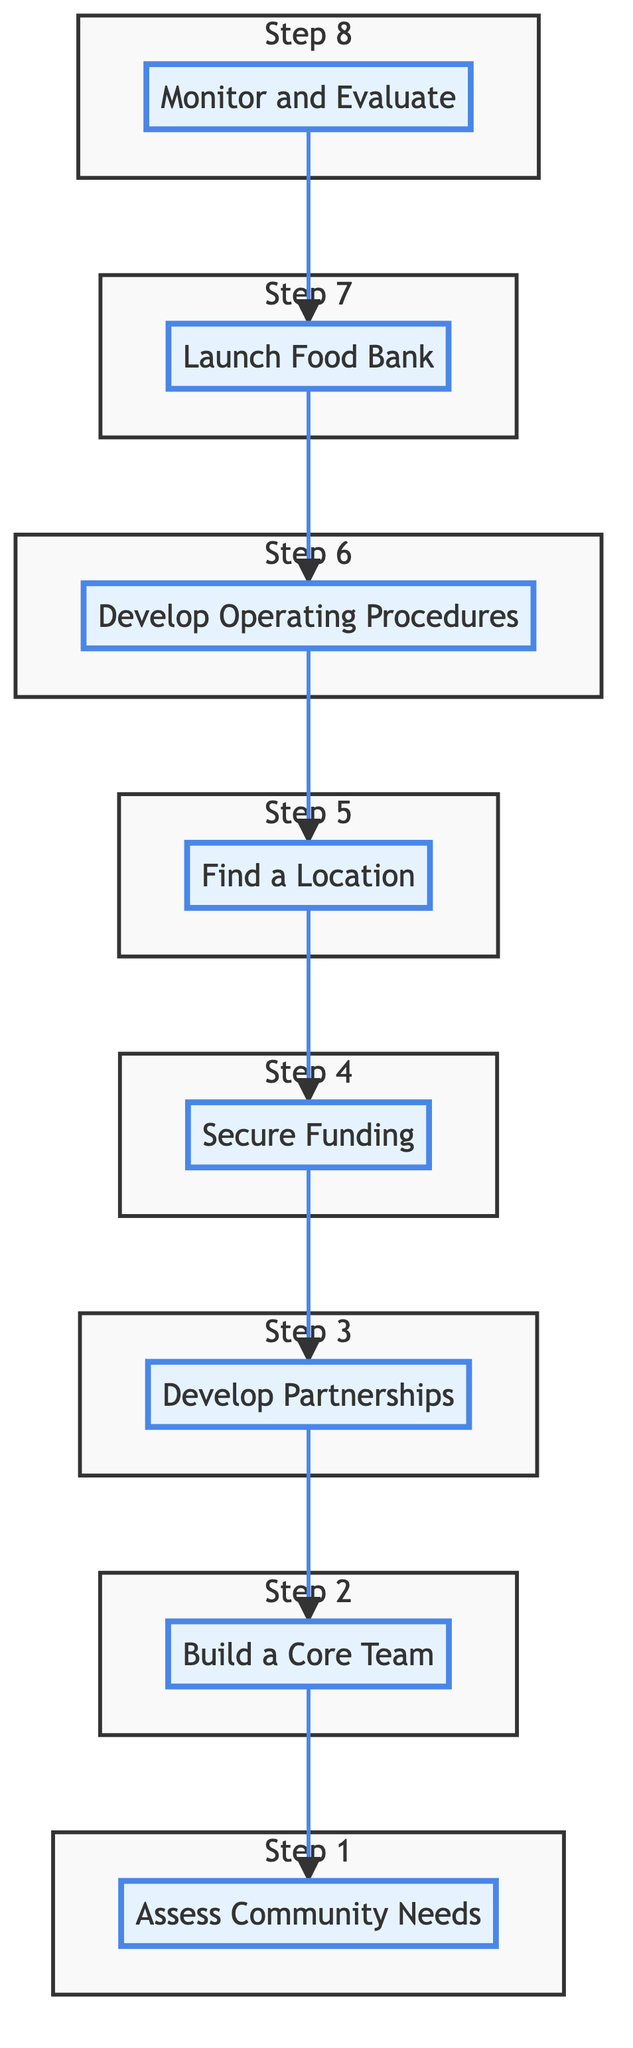What's the first step in establishing a local food bank? The diagram begins with the first node labeled "Assess Community Needs," which signifies the initial step to identify food insecurity levels and demographics.
Answer: Assess Community Needs How many total steps are in the pathway to establish a local food bank? Counting the nodes from the diagram, there are eight steps listed, each representing a key stage in establishing the food bank.
Answer: Eight Which step comes directly after securing funding? Observing the flow of the diagram, the step labeled "Find a Location" follows directly after "Secure Funding," indicating the subsequent action taken.
Answer: Find a Location What type of entities are involved in the "Develop Partnerships" step? According to the diagram, "Develop Partnerships" involves entities such as grocery stores, local farms, and charitable organizations that help secure resources and support.
Answer: Grocery Stores, Local Farms, Charitable Organizations Which step concludes the process of establishing a local food bank? The final step in the flow chart is "Monitor and Evaluate," which indicates that this is the concluding action to ensure the food bank is efficient and meets community needs.
Answer: Monitor and Evaluate What step is directly before "Launch Food Bank"? By examining the connections in the diagram, we find that "Develop Operating Procedures" is right before "Launch Food Bank," indicating the preparation necessary before operation.
Answer: Develop Operating Procedures How does the community assess food insecurity according to the first step? The first step involves assessing community needs through methods such as community surveys, local government data, and NGO reports, which are vital for understanding food insecurity levels.
Answer: Community Surveys, Local Government Data, NGO Reports What is the role of volunteers in the establishment process? Volunteers are part of the "Build a Core Team" step where they collaborate with local activists and community leaders to drive the effort to eliminate hunger in the community.
Answer: Build a Core Team 